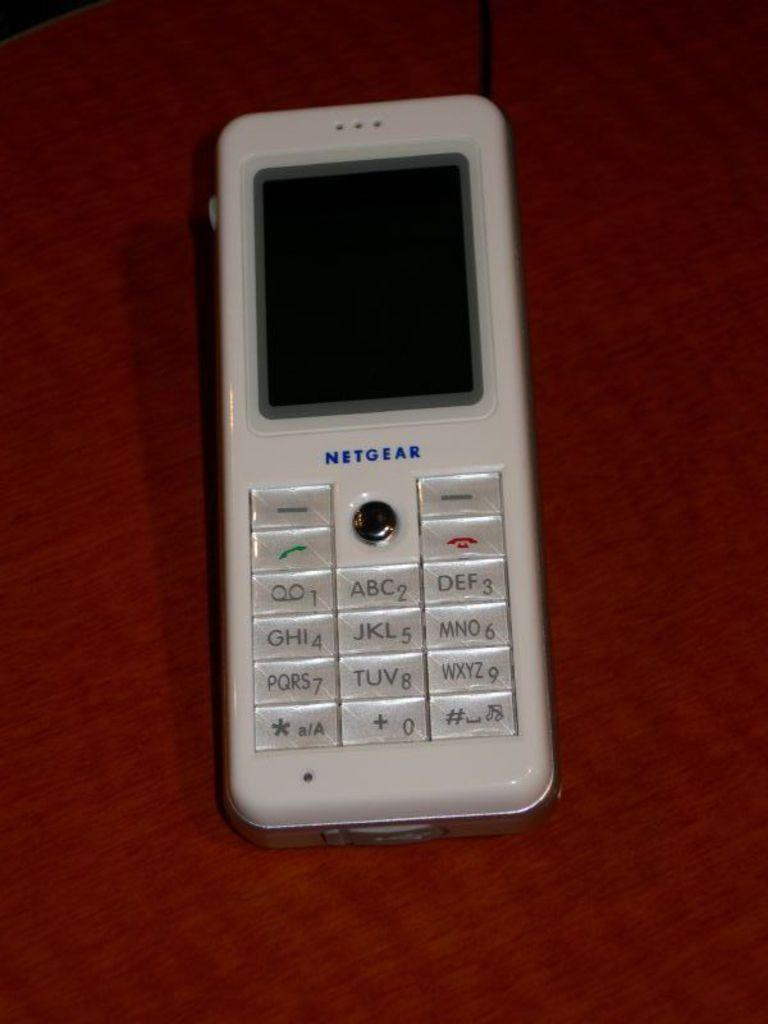<image>
Present a compact description of the photo's key features. White Netgear cellphone on top of a red surface. 